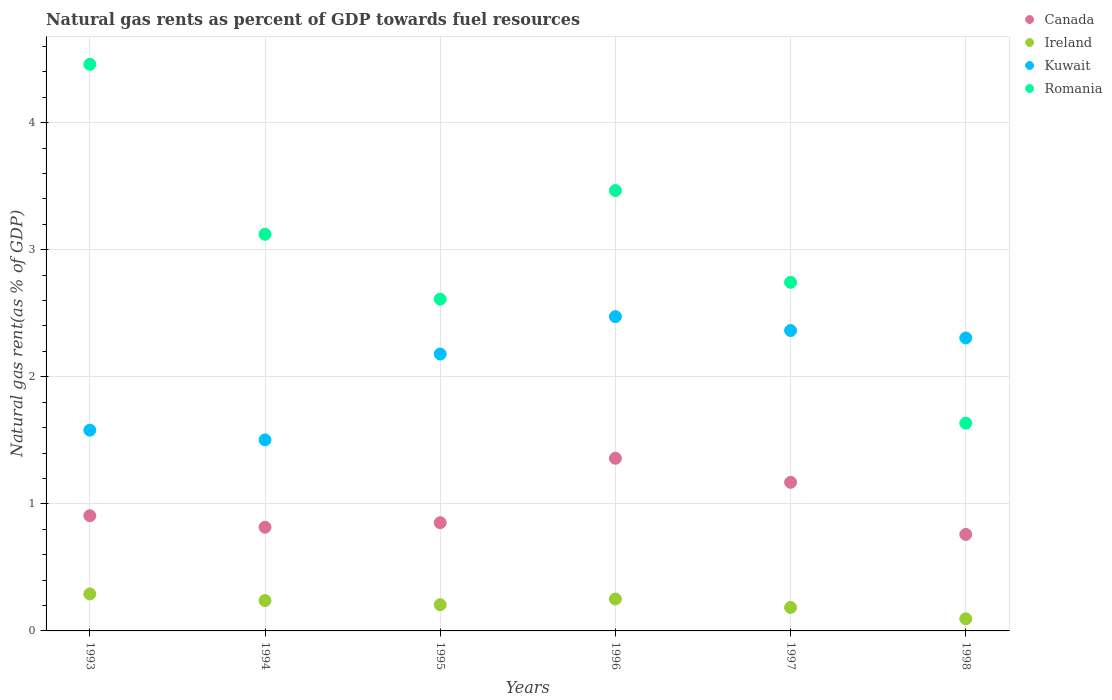How many different coloured dotlines are there?
Provide a succinct answer. 4. Is the number of dotlines equal to the number of legend labels?
Offer a very short reply. Yes. What is the natural gas rent in Kuwait in 1997?
Make the answer very short. 2.36. Across all years, what is the maximum natural gas rent in Canada?
Give a very brief answer. 1.36. Across all years, what is the minimum natural gas rent in Ireland?
Offer a terse response. 0.1. In which year was the natural gas rent in Canada maximum?
Offer a terse response. 1996. In which year was the natural gas rent in Romania minimum?
Your answer should be very brief. 1998. What is the total natural gas rent in Canada in the graph?
Your answer should be very brief. 5.86. What is the difference between the natural gas rent in Kuwait in 1994 and that in 1995?
Provide a succinct answer. -0.68. What is the difference between the natural gas rent in Kuwait in 1998 and the natural gas rent in Canada in 1996?
Provide a succinct answer. 0.95. What is the average natural gas rent in Ireland per year?
Your answer should be very brief. 0.21. In the year 1993, what is the difference between the natural gas rent in Canada and natural gas rent in Ireland?
Your answer should be compact. 0.62. What is the ratio of the natural gas rent in Romania in 1996 to that in 1997?
Your response must be concise. 1.26. Is the difference between the natural gas rent in Canada in 1996 and 1998 greater than the difference between the natural gas rent in Ireland in 1996 and 1998?
Your answer should be compact. Yes. What is the difference between the highest and the second highest natural gas rent in Romania?
Make the answer very short. 0.99. What is the difference between the highest and the lowest natural gas rent in Canada?
Your response must be concise. 0.6. Is it the case that in every year, the sum of the natural gas rent in Romania and natural gas rent in Kuwait  is greater than the sum of natural gas rent in Ireland and natural gas rent in Canada?
Your response must be concise. Yes. Is it the case that in every year, the sum of the natural gas rent in Canada and natural gas rent in Ireland  is greater than the natural gas rent in Romania?
Offer a terse response. No. Does the natural gas rent in Ireland monotonically increase over the years?
Ensure brevity in your answer.  No. Is the natural gas rent in Canada strictly greater than the natural gas rent in Ireland over the years?
Your answer should be very brief. Yes. Is the natural gas rent in Ireland strictly less than the natural gas rent in Kuwait over the years?
Your answer should be compact. Yes. How many years are there in the graph?
Offer a very short reply. 6. What is the difference between two consecutive major ticks on the Y-axis?
Ensure brevity in your answer.  1. Does the graph contain any zero values?
Your answer should be very brief. No. Does the graph contain grids?
Give a very brief answer. Yes. How are the legend labels stacked?
Provide a succinct answer. Vertical. What is the title of the graph?
Your answer should be very brief. Natural gas rents as percent of GDP towards fuel resources. Does "Bulgaria" appear as one of the legend labels in the graph?
Offer a very short reply. No. What is the label or title of the Y-axis?
Ensure brevity in your answer.  Natural gas rent(as % of GDP). What is the Natural gas rent(as % of GDP) of Canada in 1993?
Ensure brevity in your answer.  0.91. What is the Natural gas rent(as % of GDP) in Ireland in 1993?
Ensure brevity in your answer.  0.29. What is the Natural gas rent(as % of GDP) in Kuwait in 1993?
Your response must be concise. 1.58. What is the Natural gas rent(as % of GDP) in Romania in 1993?
Keep it short and to the point. 4.46. What is the Natural gas rent(as % of GDP) of Canada in 1994?
Your answer should be compact. 0.82. What is the Natural gas rent(as % of GDP) of Ireland in 1994?
Your response must be concise. 0.24. What is the Natural gas rent(as % of GDP) of Kuwait in 1994?
Provide a succinct answer. 1.5. What is the Natural gas rent(as % of GDP) of Romania in 1994?
Provide a short and direct response. 3.12. What is the Natural gas rent(as % of GDP) in Canada in 1995?
Provide a short and direct response. 0.85. What is the Natural gas rent(as % of GDP) in Ireland in 1995?
Your response must be concise. 0.21. What is the Natural gas rent(as % of GDP) in Kuwait in 1995?
Make the answer very short. 2.18. What is the Natural gas rent(as % of GDP) in Romania in 1995?
Provide a succinct answer. 2.61. What is the Natural gas rent(as % of GDP) of Canada in 1996?
Ensure brevity in your answer.  1.36. What is the Natural gas rent(as % of GDP) of Ireland in 1996?
Your answer should be compact. 0.25. What is the Natural gas rent(as % of GDP) in Kuwait in 1996?
Offer a very short reply. 2.47. What is the Natural gas rent(as % of GDP) of Romania in 1996?
Offer a terse response. 3.47. What is the Natural gas rent(as % of GDP) of Canada in 1997?
Your answer should be compact. 1.17. What is the Natural gas rent(as % of GDP) of Ireland in 1997?
Keep it short and to the point. 0.18. What is the Natural gas rent(as % of GDP) in Kuwait in 1997?
Ensure brevity in your answer.  2.36. What is the Natural gas rent(as % of GDP) of Romania in 1997?
Make the answer very short. 2.74. What is the Natural gas rent(as % of GDP) in Canada in 1998?
Ensure brevity in your answer.  0.76. What is the Natural gas rent(as % of GDP) in Ireland in 1998?
Your answer should be compact. 0.1. What is the Natural gas rent(as % of GDP) in Kuwait in 1998?
Give a very brief answer. 2.31. What is the Natural gas rent(as % of GDP) in Romania in 1998?
Give a very brief answer. 1.64. Across all years, what is the maximum Natural gas rent(as % of GDP) in Canada?
Provide a succinct answer. 1.36. Across all years, what is the maximum Natural gas rent(as % of GDP) of Ireland?
Make the answer very short. 0.29. Across all years, what is the maximum Natural gas rent(as % of GDP) in Kuwait?
Provide a succinct answer. 2.47. Across all years, what is the maximum Natural gas rent(as % of GDP) in Romania?
Your answer should be very brief. 4.46. Across all years, what is the minimum Natural gas rent(as % of GDP) of Canada?
Ensure brevity in your answer.  0.76. Across all years, what is the minimum Natural gas rent(as % of GDP) in Ireland?
Offer a terse response. 0.1. Across all years, what is the minimum Natural gas rent(as % of GDP) in Kuwait?
Offer a terse response. 1.5. Across all years, what is the minimum Natural gas rent(as % of GDP) in Romania?
Make the answer very short. 1.64. What is the total Natural gas rent(as % of GDP) in Canada in the graph?
Your answer should be compact. 5.86. What is the total Natural gas rent(as % of GDP) of Ireland in the graph?
Offer a very short reply. 1.27. What is the total Natural gas rent(as % of GDP) in Kuwait in the graph?
Your response must be concise. 12.4. What is the total Natural gas rent(as % of GDP) in Romania in the graph?
Your answer should be compact. 18.03. What is the difference between the Natural gas rent(as % of GDP) of Canada in 1993 and that in 1994?
Provide a short and direct response. 0.09. What is the difference between the Natural gas rent(as % of GDP) of Ireland in 1993 and that in 1994?
Your response must be concise. 0.05. What is the difference between the Natural gas rent(as % of GDP) of Kuwait in 1993 and that in 1994?
Provide a short and direct response. 0.08. What is the difference between the Natural gas rent(as % of GDP) of Romania in 1993 and that in 1994?
Make the answer very short. 1.34. What is the difference between the Natural gas rent(as % of GDP) of Canada in 1993 and that in 1995?
Ensure brevity in your answer.  0.06. What is the difference between the Natural gas rent(as % of GDP) in Ireland in 1993 and that in 1995?
Provide a short and direct response. 0.08. What is the difference between the Natural gas rent(as % of GDP) of Kuwait in 1993 and that in 1995?
Ensure brevity in your answer.  -0.6. What is the difference between the Natural gas rent(as % of GDP) of Romania in 1993 and that in 1995?
Give a very brief answer. 1.85. What is the difference between the Natural gas rent(as % of GDP) in Canada in 1993 and that in 1996?
Ensure brevity in your answer.  -0.45. What is the difference between the Natural gas rent(as % of GDP) of Ireland in 1993 and that in 1996?
Provide a succinct answer. 0.04. What is the difference between the Natural gas rent(as % of GDP) in Kuwait in 1993 and that in 1996?
Provide a short and direct response. -0.89. What is the difference between the Natural gas rent(as % of GDP) in Canada in 1993 and that in 1997?
Offer a terse response. -0.26. What is the difference between the Natural gas rent(as % of GDP) of Ireland in 1993 and that in 1997?
Your response must be concise. 0.11. What is the difference between the Natural gas rent(as % of GDP) in Kuwait in 1993 and that in 1997?
Your answer should be very brief. -0.78. What is the difference between the Natural gas rent(as % of GDP) of Romania in 1993 and that in 1997?
Your answer should be compact. 1.72. What is the difference between the Natural gas rent(as % of GDP) of Canada in 1993 and that in 1998?
Make the answer very short. 0.15. What is the difference between the Natural gas rent(as % of GDP) of Ireland in 1993 and that in 1998?
Ensure brevity in your answer.  0.2. What is the difference between the Natural gas rent(as % of GDP) of Kuwait in 1993 and that in 1998?
Keep it short and to the point. -0.73. What is the difference between the Natural gas rent(as % of GDP) in Romania in 1993 and that in 1998?
Ensure brevity in your answer.  2.82. What is the difference between the Natural gas rent(as % of GDP) of Canada in 1994 and that in 1995?
Offer a very short reply. -0.04. What is the difference between the Natural gas rent(as % of GDP) in Ireland in 1994 and that in 1995?
Keep it short and to the point. 0.03. What is the difference between the Natural gas rent(as % of GDP) in Kuwait in 1994 and that in 1995?
Your answer should be compact. -0.68. What is the difference between the Natural gas rent(as % of GDP) in Romania in 1994 and that in 1995?
Offer a terse response. 0.51. What is the difference between the Natural gas rent(as % of GDP) of Canada in 1994 and that in 1996?
Give a very brief answer. -0.54. What is the difference between the Natural gas rent(as % of GDP) of Ireland in 1994 and that in 1996?
Give a very brief answer. -0.01. What is the difference between the Natural gas rent(as % of GDP) of Kuwait in 1994 and that in 1996?
Provide a short and direct response. -0.97. What is the difference between the Natural gas rent(as % of GDP) of Romania in 1994 and that in 1996?
Your answer should be compact. -0.34. What is the difference between the Natural gas rent(as % of GDP) in Canada in 1994 and that in 1997?
Provide a succinct answer. -0.35. What is the difference between the Natural gas rent(as % of GDP) of Ireland in 1994 and that in 1997?
Give a very brief answer. 0.05. What is the difference between the Natural gas rent(as % of GDP) of Kuwait in 1994 and that in 1997?
Provide a succinct answer. -0.86. What is the difference between the Natural gas rent(as % of GDP) in Romania in 1994 and that in 1997?
Provide a short and direct response. 0.38. What is the difference between the Natural gas rent(as % of GDP) of Canada in 1994 and that in 1998?
Your answer should be very brief. 0.06. What is the difference between the Natural gas rent(as % of GDP) in Ireland in 1994 and that in 1998?
Provide a short and direct response. 0.14. What is the difference between the Natural gas rent(as % of GDP) of Kuwait in 1994 and that in 1998?
Offer a very short reply. -0.8. What is the difference between the Natural gas rent(as % of GDP) of Romania in 1994 and that in 1998?
Ensure brevity in your answer.  1.49. What is the difference between the Natural gas rent(as % of GDP) in Canada in 1995 and that in 1996?
Offer a very short reply. -0.51. What is the difference between the Natural gas rent(as % of GDP) of Ireland in 1995 and that in 1996?
Provide a succinct answer. -0.04. What is the difference between the Natural gas rent(as % of GDP) in Kuwait in 1995 and that in 1996?
Make the answer very short. -0.29. What is the difference between the Natural gas rent(as % of GDP) in Romania in 1995 and that in 1996?
Provide a short and direct response. -0.85. What is the difference between the Natural gas rent(as % of GDP) of Canada in 1995 and that in 1997?
Make the answer very short. -0.32. What is the difference between the Natural gas rent(as % of GDP) of Ireland in 1995 and that in 1997?
Ensure brevity in your answer.  0.02. What is the difference between the Natural gas rent(as % of GDP) in Kuwait in 1995 and that in 1997?
Ensure brevity in your answer.  -0.18. What is the difference between the Natural gas rent(as % of GDP) of Romania in 1995 and that in 1997?
Ensure brevity in your answer.  -0.13. What is the difference between the Natural gas rent(as % of GDP) of Canada in 1995 and that in 1998?
Provide a short and direct response. 0.09. What is the difference between the Natural gas rent(as % of GDP) in Ireland in 1995 and that in 1998?
Give a very brief answer. 0.11. What is the difference between the Natural gas rent(as % of GDP) in Kuwait in 1995 and that in 1998?
Keep it short and to the point. -0.13. What is the difference between the Natural gas rent(as % of GDP) of Romania in 1995 and that in 1998?
Ensure brevity in your answer.  0.98. What is the difference between the Natural gas rent(as % of GDP) in Canada in 1996 and that in 1997?
Your answer should be compact. 0.19. What is the difference between the Natural gas rent(as % of GDP) in Ireland in 1996 and that in 1997?
Give a very brief answer. 0.07. What is the difference between the Natural gas rent(as % of GDP) in Kuwait in 1996 and that in 1997?
Your response must be concise. 0.11. What is the difference between the Natural gas rent(as % of GDP) of Romania in 1996 and that in 1997?
Your answer should be very brief. 0.72. What is the difference between the Natural gas rent(as % of GDP) of Canada in 1996 and that in 1998?
Your answer should be very brief. 0.6. What is the difference between the Natural gas rent(as % of GDP) in Ireland in 1996 and that in 1998?
Ensure brevity in your answer.  0.16. What is the difference between the Natural gas rent(as % of GDP) of Kuwait in 1996 and that in 1998?
Give a very brief answer. 0.17. What is the difference between the Natural gas rent(as % of GDP) in Romania in 1996 and that in 1998?
Make the answer very short. 1.83. What is the difference between the Natural gas rent(as % of GDP) in Canada in 1997 and that in 1998?
Your answer should be compact. 0.41. What is the difference between the Natural gas rent(as % of GDP) in Ireland in 1997 and that in 1998?
Make the answer very short. 0.09. What is the difference between the Natural gas rent(as % of GDP) in Kuwait in 1997 and that in 1998?
Keep it short and to the point. 0.06. What is the difference between the Natural gas rent(as % of GDP) in Romania in 1997 and that in 1998?
Provide a short and direct response. 1.11. What is the difference between the Natural gas rent(as % of GDP) of Canada in 1993 and the Natural gas rent(as % of GDP) of Ireland in 1994?
Keep it short and to the point. 0.67. What is the difference between the Natural gas rent(as % of GDP) of Canada in 1993 and the Natural gas rent(as % of GDP) of Kuwait in 1994?
Keep it short and to the point. -0.6. What is the difference between the Natural gas rent(as % of GDP) in Canada in 1993 and the Natural gas rent(as % of GDP) in Romania in 1994?
Make the answer very short. -2.21. What is the difference between the Natural gas rent(as % of GDP) of Ireland in 1993 and the Natural gas rent(as % of GDP) of Kuwait in 1994?
Keep it short and to the point. -1.21. What is the difference between the Natural gas rent(as % of GDP) in Ireland in 1993 and the Natural gas rent(as % of GDP) in Romania in 1994?
Offer a terse response. -2.83. What is the difference between the Natural gas rent(as % of GDP) in Kuwait in 1993 and the Natural gas rent(as % of GDP) in Romania in 1994?
Ensure brevity in your answer.  -1.54. What is the difference between the Natural gas rent(as % of GDP) in Canada in 1993 and the Natural gas rent(as % of GDP) in Ireland in 1995?
Give a very brief answer. 0.7. What is the difference between the Natural gas rent(as % of GDP) in Canada in 1993 and the Natural gas rent(as % of GDP) in Kuwait in 1995?
Give a very brief answer. -1.27. What is the difference between the Natural gas rent(as % of GDP) of Canada in 1993 and the Natural gas rent(as % of GDP) of Romania in 1995?
Your answer should be compact. -1.7. What is the difference between the Natural gas rent(as % of GDP) in Ireland in 1993 and the Natural gas rent(as % of GDP) in Kuwait in 1995?
Provide a succinct answer. -1.89. What is the difference between the Natural gas rent(as % of GDP) of Ireland in 1993 and the Natural gas rent(as % of GDP) of Romania in 1995?
Provide a short and direct response. -2.32. What is the difference between the Natural gas rent(as % of GDP) of Kuwait in 1993 and the Natural gas rent(as % of GDP) of Romania in 1995?
Offer a very short reply. -1.03. What is the difference between the Natural gas rent(as % of GDP) in Canada in 1993 and the Natural gas rent(as % of GDP) in Ireland in 1996?
Provide a short and direct response. 0.66. What is the difference between the Natural gas rent(as % of GDP) in Canada in 1993 and the Natural gas rent(as % of GDP) in Kuwait in 1996?
Keep it short and to the point. -1.57. What is the difference between the Natural gas rent(as % of GDP) of Canada in 1993 and the Natural gas rent(as % of GDP) of Romania in 1996?
Offer a terse response. -2.56. What is the difference between the Natural gas rent(as % of GDP) in Ireland in 1993 and the Natural gas rent(as % of GDP) in Kuwait in 1996?
Your response must be concise. -2.18. What is the difference between the Natural gas rent(as % of GDP) in Ireland in 1993 and the Natural gas rent(as % of GDP) in Romania in 1996?
Provide a succinct answer. -3.17. What is the difference between the Natural gas rent(as % of GDP) in Kuwait in 1993 and the Natural gas rent(as % of GDP) in Romania in 1996?
Keep it short and to the point. -1.89. What is the difference between the Natural gas rent(as % of GDP) of Canada in 1993 and the Natural gas rent(as % of GDP) of Ireland in 1997?
Offer a terse response. 0.72. What is the difference between the Natural gas rent(as % of GDP) of Canada in 1993 and the Natural gas rent(as % of GDP) of Kuwait in 1997?
Keep it short and to the point. -1.46. What is the difference between the Natural gas rent(as % of GDP) of Canada in 1993 and the Natural gas rent(as % of GDP) of Romania in 1997?
Provide a succinct answer. -1.84. What is the difference between the Natural gas rent(as % of GDP) of Ireland in 1993 and the Natural gas rent(as % of GDP) of Kuwait in 1997?
Provide a succinct answer. -2.07. What is the difference between the Natural gas rent(as % of GDP) of Ireland in 1993 and the Natural gas rent(as % of GDP) of Romania in 1997?
Keep it short and to the point. -2.45. What is the difference between the Natural gas rent(as % of GDP) in Kuwait in 1993 and the Natural gas rent(as % of GDP) in Romania in 1997?
Your response must be concise. -1.16. What is the difference between the Natural gas rent(as % of GDP) of Canada in 1993 and the Natural gas rent(as % of GDP) of Ireland in 1998?
Your answer should be compact. 0.81. What is the difference between the Natural gas rent(as % of GDP) in Canada in 1993 and the Natural gas rent(as % of GDP) in Kuwait in 1998?
Provide a succinct answer. -1.4. What is the difference between the Natural gas rent(as % of GDP) of Canada in 1993 and the Natural gas rent(as % of GDP) of Romania in 1998?
Ensure brevity in your answer.  -0.73. What is the difference between the Natural gas rent(as % of GDP) of Ireland in 1993 and the Natural gas rent(as % of GDP) of Kuwait in 1998?
Keep it short and to the point. -2.01. What is the difference between the Natural gas rent(as % of GDP) of Ireland in 1993 and the Natural gas rent(as % of GDP) of Romania in 1998?
Give a very brief answer. -1.34. What is the difference between the Natural gas rent(as % of GDP) of Kuwait in 1993 and the Natural gas rent(as % of GDP) of Romania in 1998?
Provide a short and direct response. -0.06. What is the difference between the Natural gas rent(as % of GDP) of Canada in 1994 and the Natural gas rent(as % of GDP) of Ireland in 1995?
Offer a very short reply. 0.61. What is the difference between the Natural gas rent(as % of GDP) in Canada in 1994 and the Natural gas rent(as % of GDP) in Kuwait in 1995?
Provide a short and direct response. -1.36. What is the difference between the Natural gas rent(as % of GDP) of Canada in 1994 and the Natural gas rent(as % of GDP) of Romania in 1995?
Your answer should be very brief. -1.79. What is the difference between the Natural gas rent(as % of GDP) in Ireland in 1994 and the Natural gas rent(as % of GDP) in Kuwait in 1995?
Ensure brevity in your answer.  -1.94. What is the difference between the Natural gas rent(as % of GDP) of Ireland in 1994 and the Natural gas rent(as % of GDP) of Romania in 1995?
Your response must be concise. -2.37. What is the difference between the Natural gas rent(as % of GDP) in Kuwait in 1994 and the Natural gas rent(as % of GDP) in Romania in 1995?
Give a very brief answer. -1.11. What is the difference between the Natural gas rent(as % of GDP) in Canada in 1994 and the Natural gas rent(as % of GDP) in Ireland in 1996?
Make the answer very short. 0.56. What is the difference between the Natural gas rent(as % of GDP) of Canada in 1994 and the Natural gas rent(as % of GDP) of Kuwait in 1996?
Keep it short and to the point. -1.66. What is the difference between the Natural gas rent(as % of GDP) in Canada in 1994 and the Natural gas rent(as % of GDP) in Romania in 1996?
Your answer should be compact. -2.65. What is the difference between the Natural gas rent(as % of GDP) of Ireland in 1994 and the Natural gas rent(as % of GDP) of Kuwait in 1996?
Provide a succinct answer. -2.23. What is the difference between the Natural gas rent(as % of GDP) in Ireland in 1994 and the Natural gas rent(as % of GDP) in Romania in 1996?
Ensure brevity in your answer.  -3.23. What is the difference between the Natural gas rent(as % of GDP) of Kuwait in 1994 and the Natural gas rent(as % of GDP) of Romania in 1996?
Your answer should be compact. -1.96. What is the difference between the Natural gas rent(as % of GDP) of Canada in 1994 and the Natural gas rent(as % of GDP) of Ireland in 1997?
Make the answer very short. 0.63. What is the difference between the Natural gas rent(as % of GDP) of Canada in 1994 and the Natural gas rent(as % of GDP) of Kuwait in 1997?
Provide a short and direct response. -1.55. What is the difference between the Natural gas rent(as % of GDP) in Canada in 1994 and the Natural gas rent(as % of GDP) in Romania in 1997?
Provide a short and direct response. -1.93. What is the difference between the Natural gas rent(as % of GDP) of Ireland in 1994 and the Natural gas rent(as % of GDP) of Kuwait in 1997?
Provide a succinct answer. -2.12. What is the difference between the Natural gas rent(as % of GDP) of Ireland in 1994 and the Natural gas rent(as % of GDP) of Romania in 1997?
Ensure brevity in your answer.  -2.5. What is the difference between the Natural gas rent(as % of GDP) of Kuwait in 1994 and the Natural gas rent(as % of GDP) of Romania in 1997?
Offer a terse response. -1.24. What is the difference between the Natural gas rent(as % of GDP) in Canada in 1994 and the Natural gas rent(as % of GDP) in Ireland in 1998?
Offer a terse response. 0.72. What is the difference between the Natural gas rent(as % of GDP) of Canada in 1994 and the Natural gas rent(as % of GDP) of Kuwait in 1998?
Provide a succinct answer. -1.49. What is the difference between the Natural gas rent(as % of GDP) in Canada in 1994 and the Natural gas rent(as % of GDP) in Romania in 1998?
Provide a succinct answer. -0.82. What is the difference between the Natural gas rent(as % of GDP) in Ireland in 1994 and the Natural gas rent(as % of GDP) in Kuwait in 1998?
Provide a short and direct response. -2.07. What is the difference between the Natural gas rent(as % of GDP) in Ireland in 1994 and the Natural gas rent(as % of GDP) in Romania in 1998?
Offer a terse response. -1.4. What is the difference between the Natural gas rent(as % of GDP) of Kuwait in 1994 and the Natural gas rent(as % of GDP) of Romania in 1998?
Make the answer very short. -0.13. What is the difference between the Natural gas rent(as % of GDP) in Canada in 1995 and the Natural gas rent(as % of GDP) in Ireland in 1996?
Provide a succinct answer. 0.6. What is the difference between the Natural gas rent(as % of GDP) in Canada in 1995 and the Natural gas rent(as % of GDP) in Kuwait in 1996?
Provide a succinct answer. -1.62. What is the difference between the Natural gas rent(as % of GDP) of Canada in 1995 and the Natural gas rent(as % of GDP) of Romania in 1996?
Ensure brevity in your answer.  -2.61. What is the difference between the Natural gas rent(as % of GDP) of Ireland in 1995 and the Natural gas rent(as % of GDP) of Kuwait in 1996?
Your answer should be very brief. -2.27. What is the difference between the Natural gas rent(as % of GDP) of Ireland in 1995 and the Natural gas rent(as % of GDP) of Romania in 1996?
Give a very brief answer. -3.26. What is the difference between the Natural gas rent(as % of GDP) of Kuwait in 1995 and the Natural gas rent(as % of GDP) of Romania in 1996?
Keep it short and to the point. -1.29. What is the difference between the Natural gas rent(as % of GDP) of Canada in 1995 and the Natural gas rent(as % of GDP) of Ireland in 1997?
Keep it short and to the point. 0.67. What is the difference between the Natural gas rent(as % of GDP) in Canada in 1995 and the Natural gas rent(as % of GDP) in Kuwait in 1997?
Offer a very short reply. -1.51. What is the difference between the Natural gas rent(as % of GDP) in Canada in 1995 and the Natural gas rent(as % of GDP) in Romania in 1997?
Offer a very short reply. -1.89. What is the difference between the Natural gas rent(as % of GDP) of Ireland in 1995 and the Natural gas rent(as % of GDP) of Kuwait in 1997?
Provide a succinct answer. -2.16. What is the difference between the Natural gas rent(as % of GDP) of Ireland in 1995 and the Natural gas rent(as % of GDP) of Romania in 1997?
Provide a short and direct response. -2.54. What is the difference between the Natural gas rent(as % of GDP) of Kuwait in 1995 and the Natural gas rent(as % of GDP) of Romania in 1997?
Provide a succinct answer. -0.56. What is the difference between the Natural gas rent(as % of GDP) in Canada in 1995 and the Natural gas rent(as % of GDP) in Ireland in 1998?
Your answer should be compact. 0.76. What is the difference between the Natural gas rent(as % of GDP) of Canada in 1995 and the Natural gas rent(as % of GDP) of Kuwait in 1998?
Your answer should be compact. -1.45. What is the difference between the Natural gas rent(as % of GDP) in Canada in 1995 and the Natural gas rent(as % of GDP) in Romania in 1998?
Provide a succinct answer. -0.78. What is the difference between the Natural gas rent(as % of GDP) in Ireland in 1995 and the Natural gas rent(as % of GDP) in Kuwait in 1998?
Give a very brief answer. -2.1. What is the difference between the Natural gas rent(as % of GDP) in Ireland in 1995 and the Natural gas rent(as % of GDP) in Romania in 1998?
Your answer should be very brief. -1.43. What is the difference between the Natural gas rent(as % of GDP) of Kuwait in 1995 and the Natural gas rent(as % of GDP) of Romania in 1998?
Provide a succinct answer. 0.54. What is the difference between the Natural gas rent(as % of GDP) in Canada in 1996 and the Natural gas rent(as % of GDP) in Ireland in 1997?
Make the answer very short. 1.17. What is the difference between the Natural gas rent(as % of GDP) of Canada in 1996 and the Natural gas rent(as % of GDP) of Kuwait in 1997?
Provide a short and direct response. -1. What is the difference between the Natural gas rent(as % of GDP) of Canada in 1996 and the Natural gas rent(as % of GDP) of Romania in 1997?
Your answer should be compact. -1.38. What is the difference between the Natural gas rent(as % of GDP) in Ireland in 1996 and the Natural gas rent(as % of GDP) in Kuwait in 1997?
Ensure brevity in your answer.  -2.11. What is the difference between the Natural gas rent(as % of GDP) of Ireland in 1996 and the Natural gas rent(as % of GDP) of Romania in 1997?
Offer a very short reply. -2.49. What is the difference between the Natural gas rent(as % of GDP) of Kuwait in 1996 and the Natural gas rent(as % of GDP) of Romania in 1997?
Your response must be concise. -0.27. What is the difference between the Natural gas rent(as % of GDP) in Canada in 1996 and the Natural gas rent(as % of GDP) in Ireland in 1998?
Make the answer very short. 1.26. What is the difference between the Natural gas rent(as % of GDP) of Canada in 1996 and the Natural gas rent(as % of GDP) of Kuwait in 1998?
Your answer should be very brief. -0.95. What is the difference between the Natural gas rent(as % of GDP) of Canada in 1996 and the Natural gas rent(as % of GDP) of Romania in 1998?
Provide a short and direct response. -0.28. What is the difference between the Natural gas rent(as % of GDP) in Ireland in 1996 and the Natural gas rent(as % of GDP) in Kuwait in 1998?
Your answer should be compact. -2.05. What is the difference between the Natural gas rent(as % of GDP) in Ireland in 1996 and the Natural gas rent(as % of GDP) in Romania in 1998?
Your answer should be compact. -1.38. What is the difference between the Natural gas rent(as % of GDP) of Kuwait in 1996 and the Natural gas rent(as % of GDP) of Romania in 1998?
Provide a short and direct response. 0.84. What is the difference between the Natural gas rent(as % of GDP) of Canada in 1997 and the Natural gas rent(as % of GDP) of Ireland in 1998?
Offer a terse response. 1.07. What is the difference between the Natural gas rent(as % of GDP) in Canada in 1997 and the Natural gas rent(as % of GDP) in Kuwait in 1998?
Provide a succinct answer. -1.14. What is the difference between the Natural gas rent(as % of GDP) of Canada in 1997 and the Natural gas rent(as % of GDP) of Romania in 1998?
Keep it short and to the point. -0.47. What is the difference between the Natural gas rent(as % of GDP) of Ireland in 1997 and the Natural gas rent(as % of GDP) of Kuwait in 1998?
Ensure brevity in your answer.  -2.12. What is the difference between the Natural gas rent(as % of GDP) in Ireland in 1997 and the Natural gas rent(as % of GDP) in Romania in 1998?
Ensure brevity in your answer.  -1.45. What is the difference between the Natural gas rent(as % of GDP) in Kuwait in 1997 and the Natural gas rent(as % of GDP) in Romania in 1998?
Your answer should be compact. 0.73. What is the average Natural gas rent(as % of GDP) in Canada per year?
Offer a very short reply. 0.98. What is the average Natural gas rent(as % of GDP) of Ireland per year?
Make the answer very short. 0.21. What is the average Natural gas rent(as % of GDP) of Kuwait per year?
Provide a short and direct response. 2.07. What is the average Natural gas rent(as % of GDP) in Romania per year?
Your answer should be compact. 3.01. In the year 1993, what is the difference between the Natural gas rent(as % of GDP) of Canada and Natural gas rent(as % of GDP) of Ireland?
Your response must be concise. 0.62. In the year 1993, what is the difference between the Natural gas rent(as % of GDP) in Canada and Natural gas rent(as % of GDP) in Kuwait?
Give a very brief answer. -0.67. In the year 1993, what is the difference between the Natural gas rent(as % of GDP) in Canada and Natural gas rent(as % of GDP) in Romania?
Offer a terse response. -3.55. In the year 1993, what is the difference between the Natural gas rent(as % of GDP) in Ireland and Natural gas rent(as % of GDP) in Kuwait?
Your response must be concise. -1.29. In the year 1993, what is the difference between the Natural gas rent(as % of GDP) of Ireland and Natural gas rent(as % of GDP) of Romania?
Give a very brief answer. -4.17. In the year 1993, what is the difference between the Natural gas rent(as % of GDP) in Kuwait and Natural gas rent(as % of GDP) in Romania?
Your response must be concise. -2.88. In the year 1994, what is the difference between the Natural gas rent(as % of GDP) of Canada and Natural gas rent(as % of GDP) of Ireland?
Ensure brevity in your answer.  0.58. In the year 1994, what is the difference between the Natural gas rent(as % of GDP) of Canada and Natural gas rent(as % of GDP) of Kuwait?
Your answer should be very brief. -0.69. In the year 1994, what is the difference between the Natural gas rent(as % of GDP) in Canada and Natural gas rent(as % of GDP) in Romania?
Offer a very short reply. -2.31. In the year 1994, what is the difference between the Natural gas rent(as % of GDP) of Ireland and Natural gas rent(as % of GDP) of Kuwait?
Offer a terse response. -1.26. In the year 1994, what is the difference between the Natural gas rent(as % of GDP) of Ireland and Natural gas rent(as % of GDP) of Romania?
Your response must be concise. -2.88. In the year 1994, what is the difference between the Natural gas rent(as % of GDP) of Kuwait and Natural gas rent(as % of GDP) of Romania?
Your response must be concise. -1.62. In the year 1995, what is the difference between the Natural gas rent(as % of GDP) in Canada and Natural gas rent(as % of GDP) in Ireland?
Your answer should be very brief. 0.65. In the year 1995, what is the difference between the Natural gas rent(as % of GDP) of Canada and Natural gas rent(as % of GDP) of Kuwait?
Give a very brief answer. -1.33. In the year 1995, what is the difference between the Natural gas rent(as % of GDP) of Canada and Natural gas rent(as % of GDP) of Romania?
Give a very brief answer. -1.76. In the year 1995, what is the difference between the Natural gas rent(as % of GDP) in Ireland and Natural gas rent(as % of GDP) in Kuwait?
Keep it short and to the point. -1.97. In the year 1995, what is the difference between the Natural gas rent(as % of GDP) in Ireland and Natural gas rent(as % of GDP) in Romania?
Your answer should be compact. -2.4. In the year 1995, what is the difference between the Natural gas rent(as % of GDP) of Kuwait and Natural gas rent(as % of GDP) of Romania?
Your response must be concise. -0.43. In the year 1996, what is the difference between the Natural gas rent(as % of GDP) in Canada and Natural gas rent(as % of GDP) in Ireland?
Provide a succinct answer. 1.11. In the year 1996, what is the difference between the Natural gas rent(as % of GDP) in Canada and Natural gas rent(as % of GDP) in Kuwait?
Offer a very short reply. -1.11. In the year 1996, what is the difference between the Natural gas rent(as % of GDP) of Canada and Natural gas rent(as % of GDP) of Romania?
Give a very brief answer. -2.11. In the year 1996, what is the difference between the Natural gas rent(as % of GDP) of Ireland and Natural gas rent(as % of GDP) of Kuwait?
Keep it short and to the point. -2.22. In the year 1996, what is the difference between the Natural gas rent(as % of GDP) in Ireland and Natural gas rent(as % of GDP) in Romania?
Your answer should be compact. -3.21. In the year 1996, what is the difference between the Natural gas rent(as % of GDP) in Kuwait and Natural gas rent(as % of GDP) in Romania?
Your response must be concise. -0.99. In the year 1997, what is the difference between the Natural gas rent(as % of GDP) in Canada and Natural gas rent(as % of GDP) in Ireland?
Your answer should be very brief. 0.98. In the year 1997, what is the difference between the Natural gas rent(as % of GDP) of Canada and Natural gas rent(as % of GDP) of Kuwait?
Keep it short and to the point. -1.19. In the year 1997, what is the difference between the Natural gas rent(as % of GDP) in Canada and Natural gas rent(as % of GDP) in Romania?
Your response must be concise. -1.57. In the year 1997, what is the difference between the Natural gas rent(as % of GDP) of Ireland and Natural gas rent(as % of GDP) of Kuwait?
Offer a very short reply. -2.18. In the year 1997, what is the difference between the Natural gas rent(as % of GDP) in Ireland and Natural gas rent(as % of GDP) in Romania?
Make the answer very short. -2.56. In the year 1997, what is the difference between the Natural gas rent(as % of GDP) of Kuwait and Natural gas rent(as % of GDP) of Romania?
Offer a very short reply. -0.38. In the year 1998, what is the difference between the Natural gas rent(as % of GDP) in Canada and Natural gas rent(as % of GDP) in Ireland?
Your answer should be very brief. 0.66. In the year 1998, what is the difference between the Natural gas rent(as % of GDP) of Canada and Natural gas rent(as % of GDP) of Kuwait?
Ensure brevity in your answer.  -1.55. In the year 1998, what is the difference between the Natural gas rent(as % of GDP) of Canada and Natural gas rent(as % of GDP) of Romania?
Ensure brevity in your answer.  -0.88. In the year 1998, what is the difference between the Natural gas rent(as % of GDP) of Ireland and Natural gas rent(as % of GDP) of Kuwait?
Your answer should be compact. -2.21. In the year 1998, what is the difference between the Natural gas rent(as % of GDP) of Ireland and Natural gas rent(as % of GDP) of Romania?
Keep it short and to the point. -1.54. In the year 1998, what is the difference between the Natural gas rent(as % of GDP) of Kuwait and Natural gas rent(as % of GDP) of Romania?
Ensure brevity in your answer.  0.67. What is the ratio of the Natural gas rent(as % of GDP) in Canada in 1993 to that in 1994?
Provide a short and direct response. 1.11. What is the ratio of the Natural gas rent(as % of GDP) in Ireland in 1993 to that in 1994?
Provide a succinct answer. 1.22. What is the ratio of the Natural gas rent(as % of GDP) of Kuwait in 1993 to that in 1994?
Your answer should be very brief. 1.05. What is the ratio of the Natural gas rent(as % of GDP) in Romania in 1993 to that in 1994?
Ensure brevity in your answer.  1.43. What is the ratio of the Natural gas rent(as % of GDP) of Canada in 1993 to that in 1995?
Your answer should be compact. 1.06. What is the ratio of the Natural gas rent(as % of GDP) in Ireland in 1993 to that in 1995?
Provide a short and direct response. 1.41. What is the ratio of the Natural gas rent(as % of GDP) of Kuwait in 1993 to that in 1995?
Ensure brevity in your answer.  0.72. What is the ratio of the Natural gas rent(as % of GDP) of Romania in 1993 to that in 1995?
Give a very brief answer. 1.71. What is the ratio of the Natural gas rent(as % of GDP) in Canada in 1993 to that in 1996?
Ensure brevity in your answer.  0.67. What is the ratio of the Natural gas rent(as % of GDP) in Ireland in 1993 to that in 1996?
Offer a very short reply. 1.16. What is the ratio of the Natural gas rent(as % of GDP) in Kuwait in 1993 to that in 1996?
Make the answer very short. 0.64. What is the ratio of the Natural gas rent(as % of GDP) in Romania in 1993 to that in 1996?
Keep it short and to the point. 1.29. What is the ratio of the Natural gas rent(as % of GDP) in Canada in 1993 to that in 1997?
Keep it short and to the point. 0.78. What is the ratio of the Natural gas rent(as % of GDP) of Ireland in 1993 to that in 1997?
Your answer should be very brief. 1.57. What is the ratio of the Natural gas rent(as % of GDP) of Kuwait in 1993 to that in 1997?
Offer a very short reply. 0.67. What is the ratio of the Natural gas rent(as % of GDP) of Romania in 1993 to that in 1997?
Provide a short and direct response. 1.63. What is the ratio of the Natural gas rent(as % of GDP) in Canada in 1993 to that in 1998?
Ensure brevity in your answer.  1.19. What is the ratio of the Natural gas rent(as % of GDP) of Ireland in 1993 to that in 1998?
Your answer should be very brief. 3.06. What is the ratio of the Natural gas rent(as % of GDP) in Kuwait in 1993 to that in 1998?
Provide a succinct answer. 0.69. What is the ratio of the Natural gas rent(as % of GDP) in Romania in 1993 to that in 1998?
Offer a terse response. 2.73. What is the ratio of the Natural gas rent(as % of GDP) in Ireland in 1994 to that in 1995?
Provide a short and direct response. 1.16. What is the ratio of the Natural gas rent(as % of GDP) of Kuwait in 1994 to that in 1995?
Give a very brief answer. 0.69. What is the ratio of the Natural gas rent(as % of GDP) in Romania in 1994 to that in 1995?
Offer a terse response. 1.2. What is the ratio of the Natural gas rent(as % of GDP) in Canada in 1994 to that in 1996?
Offer a terse response. 0.6. What is the ratio of the Natural gas rent(as % of GDP) of Ireland in 1994 to that in 1996?
Make the answer very short. 0.95. What is the ratio of the Natural gas rent(as % of GDP) in Kuwait in 1994 to that in 1996?
Keep it short and to the point. 0.61. What is the ratio of the Natural gas rent(as % of GDP) in Romania in 1994 to that in 1996?
Offer a very short reply. 0.9. What is the ratio of the Natural gas rent(as % of GDP) in Canada in 1994 to that in 1997?
Your response must be concise. 0.7. What is the ratio of the Natural gas rent(as % of GDP) in Ireland in 1994 to that in 1997?
Your response must be concise. 1.29. What is the ratio of the Natural gas rent(as % of GDP) in Kuwait in 1994 to that in 1997?
Provide a succinct answer. 0.64. What is the ratio of the Natural gas rent(as % of GDP) in Romania in 1994 to that in 1997?
Make the answer very short. 1.14. What is the ratio of the Natural gas rent(as % of GDP) in Canada in 1994 to that in 1998?
Keep it short and to the point. 1.07. What is the ratio of the Natural gas rent(as % of GDP) in Ireland in 1994 to that in 1998?
Offer a very short reply. 2.51. What is the ratio of the Natural gas rent(as % of GDP) in Kuwait in 1994 to that in 1998?
Ensure brevity in your answer.  0.65. What is the ratio of the Natural gas rent(as % of GDP) of Romania in 1994 to that in 1998?
Ensure brevity in your answer.  1.91. What is the ratio of the Natural gas rent(as % of GDP) of Canada in 1995 to that in 1996?
Your answer should be very brief. 0.63. What is the ratio of the Natural gas rent(as % of GDP) of Ireland in 1995 to that in 1996?
Keep it short and to the point. 0.82. What is the ratio of the Natural gas rent(as % of GDP) of Kuwait in 1995 to that in 1996?
Make the answer very short. 0.88. What is the ratio of the Natural gas rent(as % of GDP) in Romania in 1995 to that in 1996?
Give a very brief answer. 0.75. What is the ratio of the Natural gas rent(as % of GDP) in Canada in 1995 to that in 1997?
Keep it short and to the point. 0.73. What is the ratio of the Natural gas rent(as % of GDP) in Ireland in 1995 to that in 1997?
Your answer should be compact. 1.12. What is the ratio of the Natural gas rent(as % of GDP) of Kuwait in 1995 to that in 1997?
Your answer should be very brief. 0.92. What is the ratio of the Natural gas rent(as % of GDP) of Romania in 1995 to that in 1997?
Offer a terse response. 0.95. What is the ratio of the Natural gas rent(as % of GDP) in Canada in 1995 to that in 1998?
Offer a terse response. 1.12. What is the ratio of the Natural gas rent(as % of GDP) in Ireland in 1995 to that in 1998?
Make the answer very short. 2.17. What is the ratio of the Natural gas rent(as % of GDP) in Kuwait in 1995 to that in 1998?
Offer a very short reply. 0.94. What is the ratio of the Natural gas rent(as % of GDP) in Romania in 1995 to that in 1998?
Offer a very short reply. 1.6. What is the ratio of the Natural gas rent(as % of GDP) of Canada in 1996 to that in 1997?
Give a very brief answer. 1.16. What is the ratio of the Natural gas rent(as % of GDP) in Ireland in 1996 to that in 1997?
Provide a succinct answer. 1.36. What is the ratio of the Natural gas rent(as % of GDP) of Kuwait in 1996 to that in 1997?
Your answer should be very brief. 1.05. What is the ratio of the Natural gas rent(as % of GDP) of Romania in 1996 to that in 1997?
Provide a succinct answer. 1.26. What is the ratio of the Natural gas rent(as % of GDP) in Canada in 1996 to that in 1998?
Provide a succinct answer. 1.79. What is the ratio of the Natural gas rent(as % of GDP) of Ireland in 1996 to that in 1998?
Provide a short and direct response. 2.64. What is the ratio of the Natural gas rent(as % of GDP) in Kuwait in 1996 to that in 1998?
Your response must be concise. 1.07. What is the ratio of the Natural gas rent(as % of GDP) of Romania in 1996 to that in 1998?
Offer a very short reply. 2.12. What is the ratio of the Natural gas rent(as % of GDP) of Canada in 1997 to that in 1998?
Offer a very short reply. 1.54. What is the ratio of the Natural gas rent(as % of GDP) in Ireland in 1997 to that in 1998?
Offer a very short reply. 1.94. What is the ratio of the Natural gas rent(as % of GDP) of Kuwait in 1997 to that in 1998?
Provide a succinct answer. 1.03. What is the ratio of the Natural gas rent(as % of GDP) of Romania in 1997 to that in 1998?
Your answer should be compact. 1.68. What is the difference between the highest and the second highest Natural gas rent(as % of GDP) of Canada?
Your response must be concise. 0.19. What is the difference between the highest and the second highest Natural gas rent(as % of GDP) of Ireland?
Provide a succinct answer. 0.04. What is the difference between the highest and the second highest Natural gas rent(as % of GDP) in Kuwait?
Provide a short and direct response. 0.11. What is the difference between the highest and the second highest Natural gas rent(as % of GDP) in Romania?
Give a very brief answer. 0.99. What is the difference between the highest and the lowest Natural gas rent(as % of GDP) in Canada?
Ensure brevity in your answer.  0.6. What is the difference between the highest and the lowest Natural gas rent(as % of GDP) of Ireland?
Offer a very short reply. 0.2. What is the difference between the highest and the lowest Natural gas rent(as % of GDP) in Kuwait?
Your answer should be very brief. 0.97. What is the difference between the highest and the lowest Natural gas rent(as % of GDP) in Romania?
Your answer should be very brief. 2.82. 